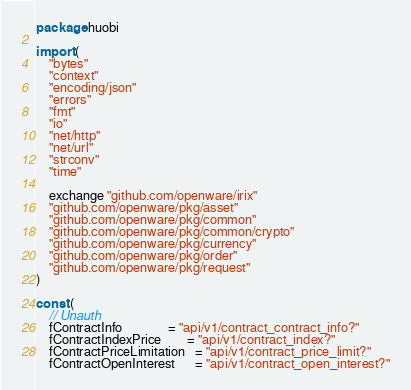Convert code to text. <code><loc_0><loc_0><loc_500><loc_500><_Go_>package huobi

import (
	"bytes"
	"context"
	"encoding/json"
	"errors"
	"fmt"
	"io"
	"net/http"
	"net/url"
	"strconv"
	"time"

	exchange "github.com/openware/irix"
	"github.com/openware/pkg/asset"
	"github.com/openware/pkg/common"
	"github.com/openware/pkg/common/crypto"
	"github.com/openware/pkg/currency"
	"github.com/openware/pkg/order"
	"github.com/openware/pkg/request"
)

const (
	// Unauth
	fContractInfo              = "api/v1/contract_contract_info?"
	fContractIndexPrice        = "api/v1/contract_index?"
	fContractPriceLimitation   = "api/v1/contract_price_limit?"
	fContractOpenInterest      = "api/v1/contract_open_interest?"</code> 